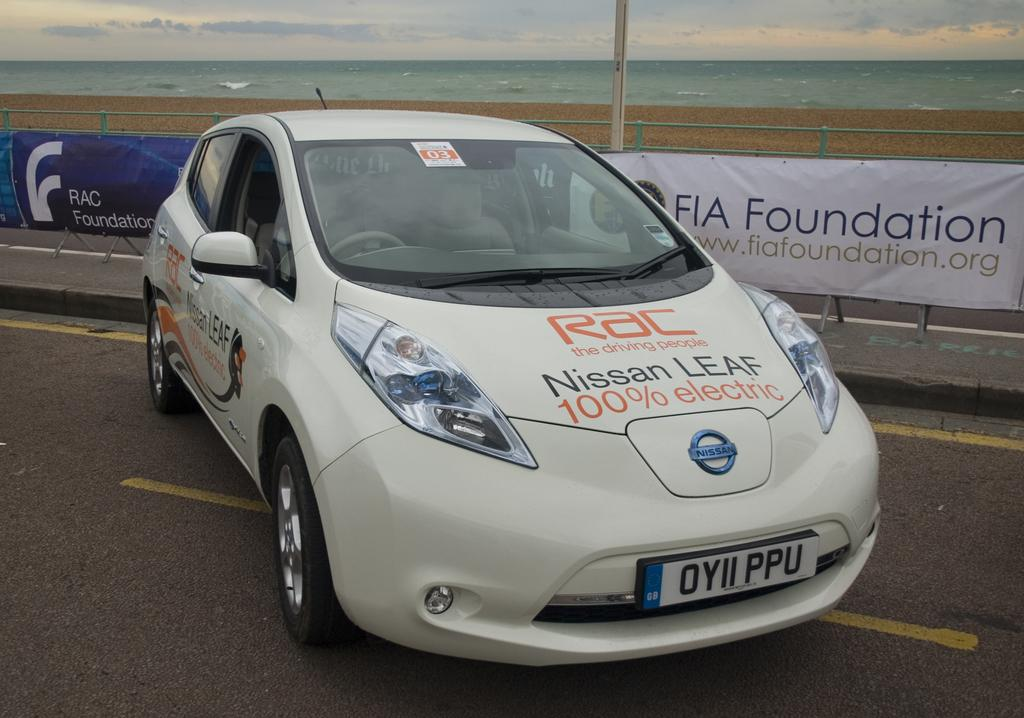What is on the ground in the image? There is a car on the ground in the image. What can be seen in the background of the image? There is a fence, a banner, water, and the sky visible in the background of the image. What is the rate at which the clouds are moving in the image? There are no clouds visible in the image, so it is not possible to determine the rate at which they might be moving. 